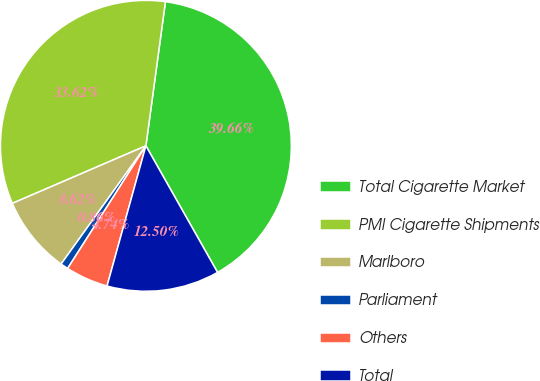<chart> <loc_0><loc_0><loc_500><loc_500><pie_chart><fcel>Total Cigarette Market<fcel>PMI Cigarette Shipments<fcel>Marlboro<fcel>Parliament<fcel>Others<fcel>Total<nl><fcel>39.66%<fcel>33.62%<fcel>8.62%<fcel>0.86%<fcel>4.74%<fcel>12.5%<nl></chart> 